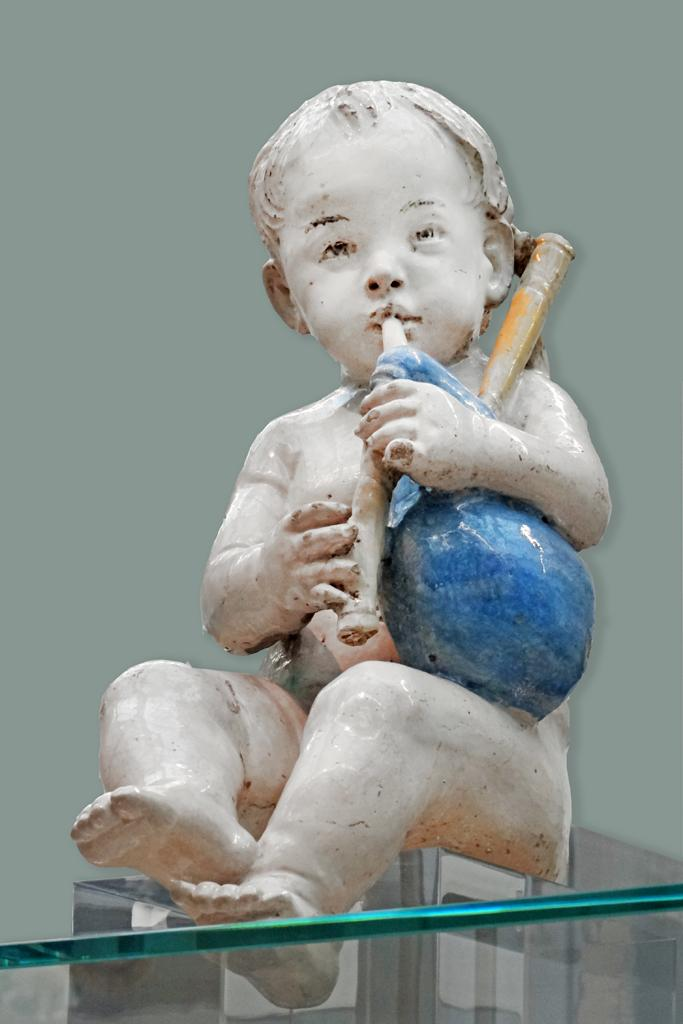What is the main subject of the image? There is a statue of a kid in the image. Can you describe any other objects in the image? There is a glass at the bottom of the image. What type of food is being cooked in the fire in the image? There is no fire or food present in the image; it only features a statue of a kid and a glass. 